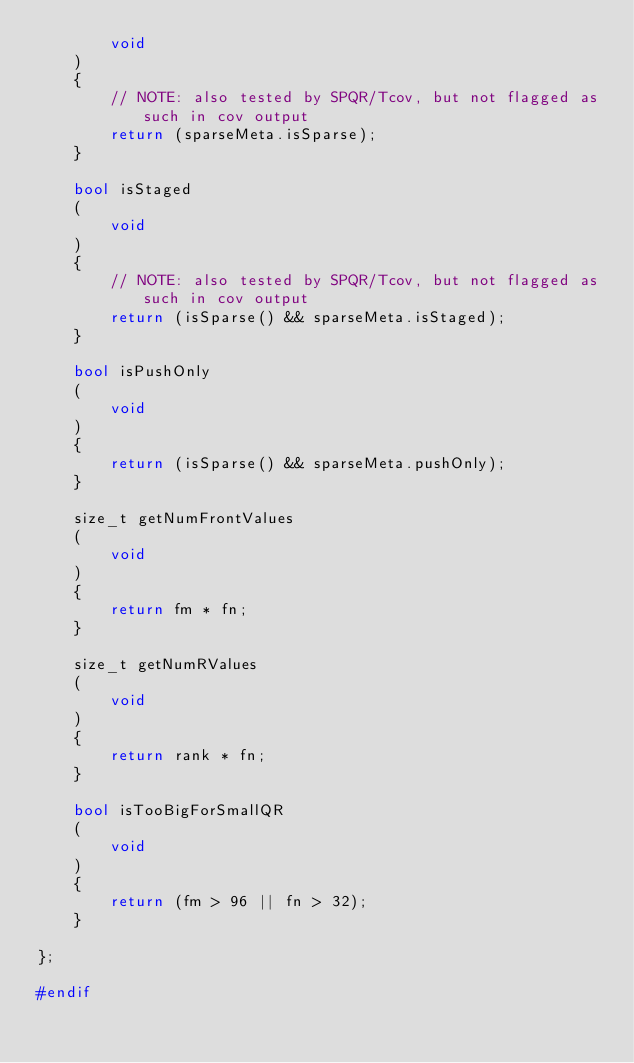<code> <loc_0><loc_0><loc_500><loc_500><_C++_>        void
    )
    {
        // NOTE: also tested by SPQR/Tcov, but not flagged as such in cov output
        return (sparseMeta.isSparse);
    }

    bool isStaged
    (
        void
    )
    {
        // NOTE: also tested by SPQR/Tcov, but not flagged as such in cov output
        return (isSparse() && sparseMeta.isStaged);
    }

    bool isPushOnly
    (
        void
    )
    {
        return (isSparse() && sparseMeta.pushOnly);
    }

    size_t getNumFrontValues
    (
        void
    )
    {
        return fm * fn;
    }

    size_t getNumRValues
    (
        void
    )
    {
        return rank * fn;
    }

    bool isTooBigForSmallQR
    (
        void
    )
    {
        return (fm > 96 || fn > 32);
    }

};

#endif
</code> 